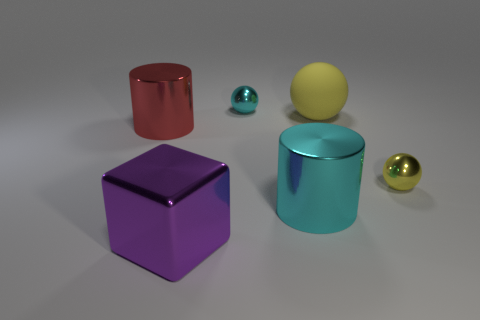There is a large rubber thing; is its color the same as the small sphere right of the large cyan metallic cylinder?
Your answer should be compact. Yes. Does the red object have the same shape as the purple thing?
Keep it short and to the point. No. What size is the cyan cylinder that is the same material as the large purple object?
Make the answer very short. Large. Is the number of small rubber cylinders less than the number of large balls?
Your answer should be compact. Yes. How many tiny things are purple rubber cylinders or rubber spheres?
Provide a short and direct response. 0. How many large things are in front of the large matte sphere and behind the block?
Provide a short and direct response. 2. Is the number of large cylinders greater than the number of big purple metallic cubes?
Keep it short and to the point. Yes. What number of other things are the same shape as the large matte object?
Your response must be concise. 2. Does the metal cube have the same color as the large matte object?
Give a very brief answer. No. There is a large object that is both behind the tiny yellow object and on the left side of the large cyan cylinder; what is its material?
Your response must be concise. Metal. 